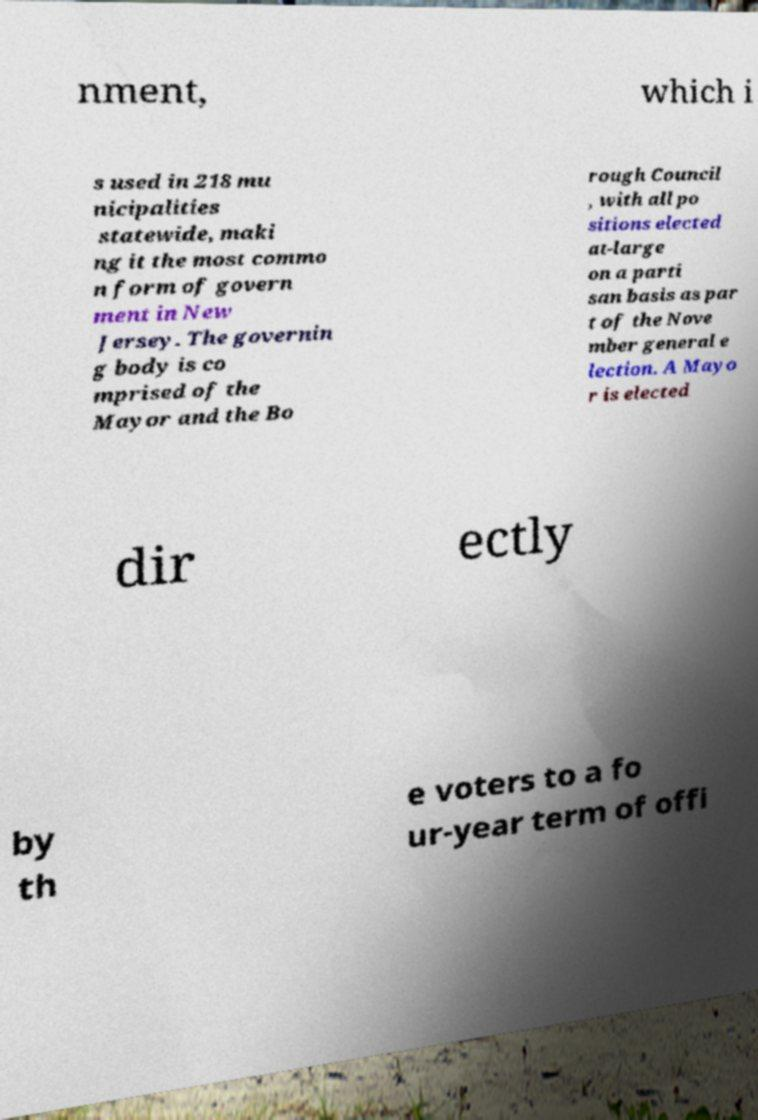For documentation purposes, I need the text within this image transcribed. Could you provide that? nment, which i s used in 218 mu nicipalities statewide, maki ng it the most commo n form of govern ment in New Jersey. The governin g body is co mprised of the Mayor and the Bo rough Council , with all po sitions elected at-large on a parti san basis as par t of the Nove mber general e lection. A Mayo r is elected dir ectly by th e voters to a fo ur-year term of offi 